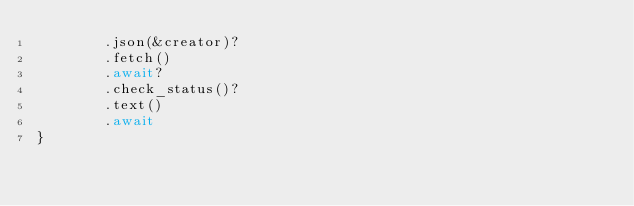Convert code to text. <code><loc_0><loc_0><loc_500><loc_500><_Rust_>        .json(&creator)?
        .fetch()
        .await?
        .check_status()?
        .text()
        .await
}
</code> 